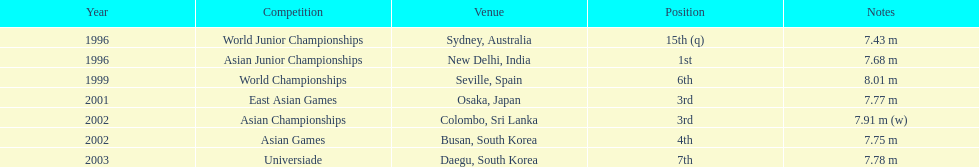In which sole contest did this participant attain the top position? Asian Junior Championships. 